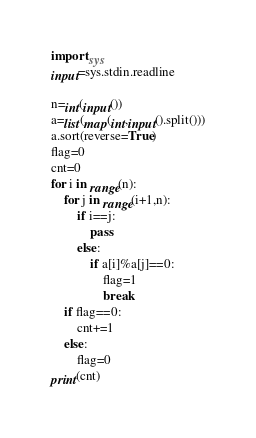<code> <loc_0><loc_0><loc_500><loc_500><_Python_>import sys
input=sys.stdin.readline

n=int(input())
a=list(map(int,input().split()))
a.sort(reverse=True)
flag=0
cnt=0
for i in range(n):
    for j in range(i+1,n):
        if i==j:
            pass
        else:
            if a[i]%a[j]==0:
                flag=1
                break
    if flag==0:
        cnt+=1
    else:
        flag=0
print(cnt)
</code> 